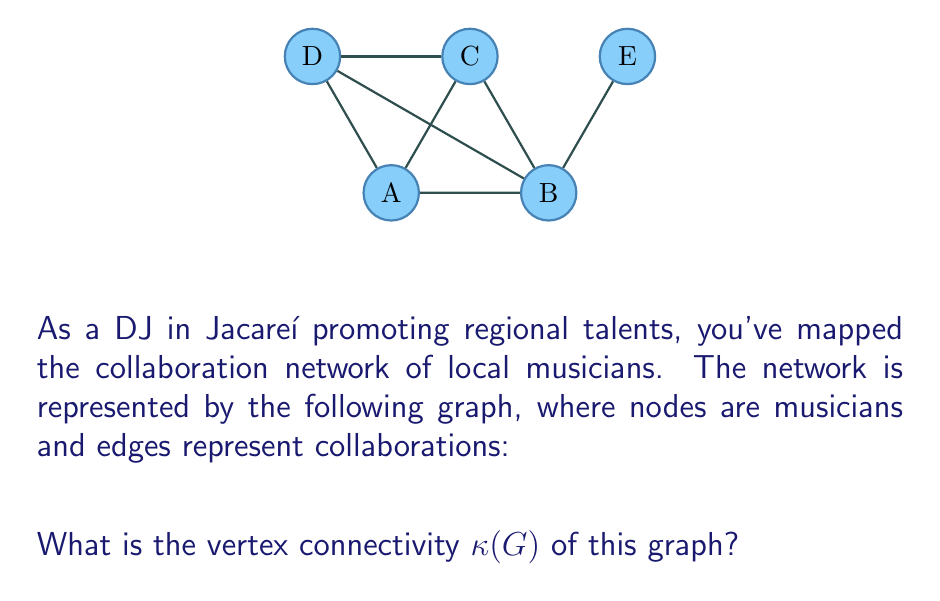Solve this math problem. To find the vertex connectivity $\kappa(G)$ of the graph, we need to determine the minimum number of vertices whose removal would disconnect the graph or reduce it to a single vertex.

Let's analyze the graph step-by-step:

1) First, observe that the graph has 5 vertices (A, B, C, D, E).

2) Notice that vertex E is connected to the rest of the graph only through vertex B. This means that removing B would disconnect E from the rest of the graph.

3) Similarly, removing vertices A and C together would disconnect D from the rest of the graph.

4) However, we need to find the minimum number of vertices to remove to disconnect the graph.

5) We can see that removing just vertex B would disconnect the graph into two components: {E} and {A, C, D}.

6) There is no single vertex other than B whose removal would disconnect the graph.

7) Therefore, the minimum number of vertices that need to be removed to disconnect the graph is 1.

By definition, the vertex connectivity $\kappa(G)$ is this minimum number.
Answer: $\kappa(G) = 1$ 